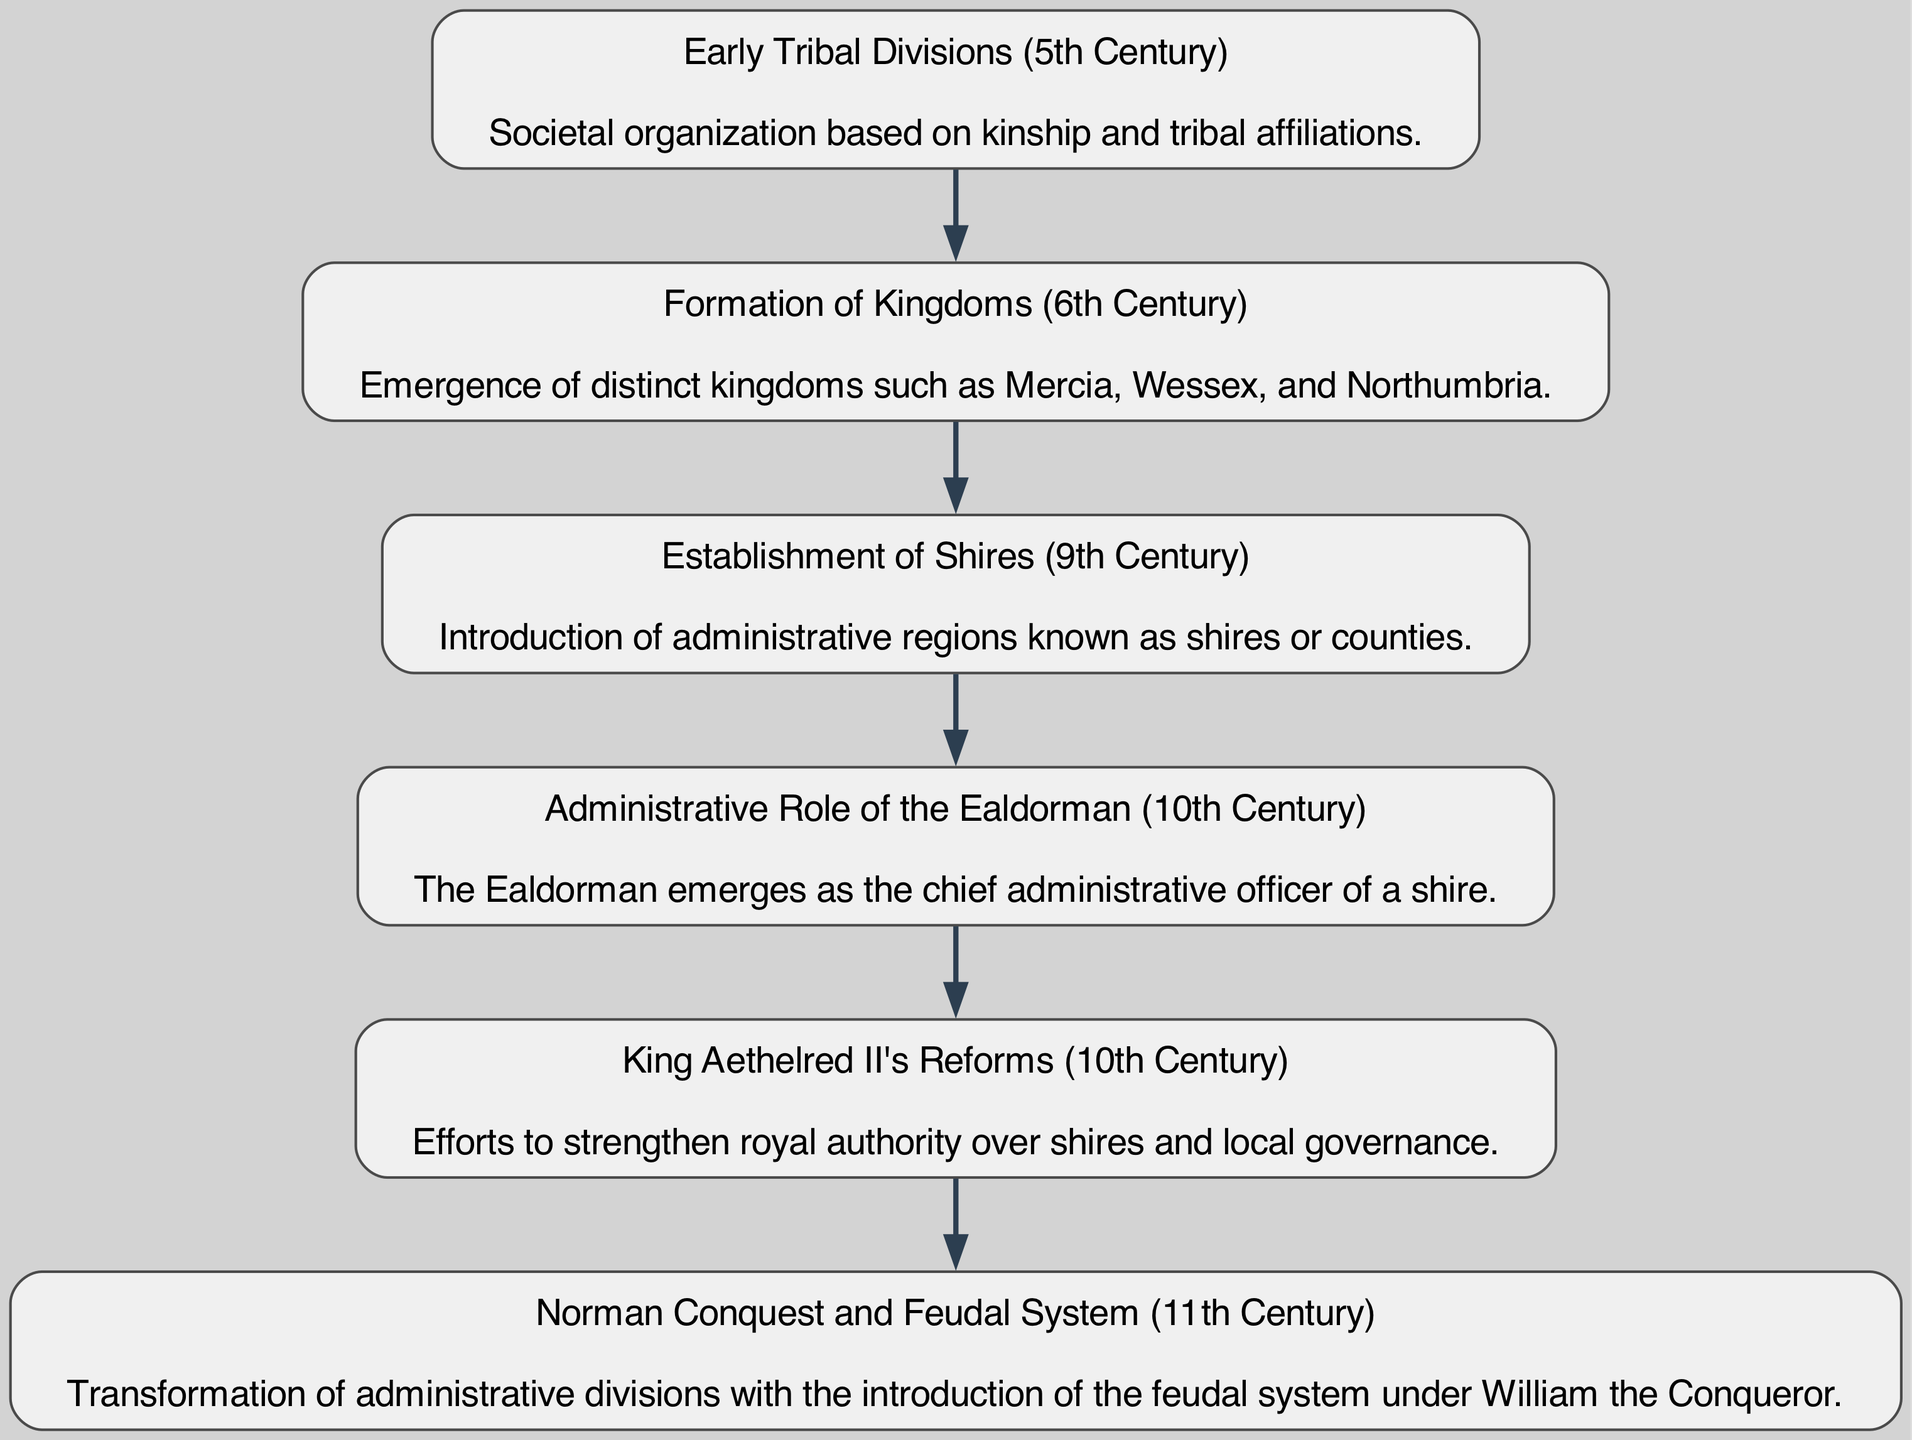What is the first administrative division depicted in the diagram? The first administrative division in the diagram is "Early Tribal Divisions (5th Century)". This division is located at the top of the flow chart, indicating it is the starting point of administrative evolution in Anglo-Saxon England.
Answer: Early Tribal Divisions (5th Century) How many total nodes are in the diagram? The diagram contains a total of six nodes, each representing a significant administrative division or reform in the timeline of Anglo-Saxon England. These nodes are connected in a sequence from the 5th century to the 11th century.
Answer: 6 What major change occurred in the 9th century? The major change that occurred in the 9th century is the "Establishment of Shires (9th Century)", which introduced organized administrative regions known as shires or counties into Anglo-Saxon governance.
Answer: Establishment of Shires (9th Century) Which node follows the "Formation of Kingdoms (6th Century)"? The node that follows the "Formation of Kingdoms (6th Century)" in the diagram is the "Establishment of Shires (9th Century)". This indicates a progression from distinct kingdoms to more structured administrative regions.
Answer: Establishment of Shires (9th Century) What administrative role emerged in the 10th century? The administrative role that emerged in the 10th century is "Administrative Role of the Ealdorman (10th Century)", which indicates a shift towards appointed local governance and leadership within the shires.
Answer: Administrative Role of the Ealdorman (10th Century) What reform did King Aethelred II implement in the 10th century? King Aethelred II implemented "Reforms" aimed at strengthening royal authority over shires and local governance. This reflects efforts to centralize control and improve the administrative structure in Anglo-Saxon England.
Answer: Reforms How did the Norman Conquest affect administrative divisions? The Norman Conquest led to the "transformation of administrative divisions" with the introduction of the feudal system under William the Conqueror, highlighting a significant change in governance and land distribution in post-conquest England.
Answer: Transformation of administrative divisions What is the last change depicted in the diagram? The last change depicted in the diagram is the "Norman Conquest and Feudal System (11th Century)", marking the end of the flow chart and representing a pivotal moment in the evolution of governance in England.
Answer: Norman Conquest and Feudal System (11th Century) 